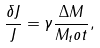<formula> <loc_0><loc_0><loc_500><loc_500>\frac { \delta J } { J } = \gamma \frac { \Delta M } { M _ { t } o t } ,</formula> 